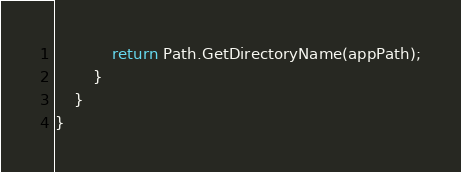<code> <loc_0><loc_0><loc_500><loc_500><_C#_>            return Path.GetDirectoryName(appPath);
        }
    }
}</code> 